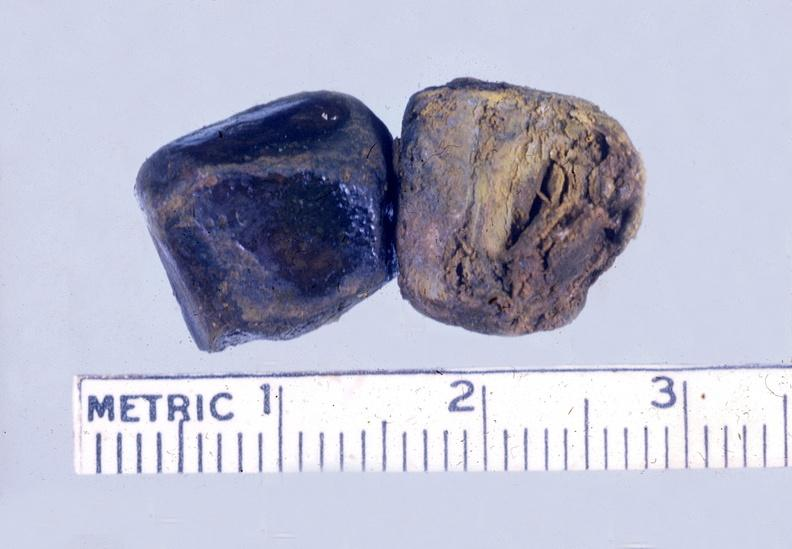what is present?
Answer the question using a single word or phrase. Hepatobiliary 